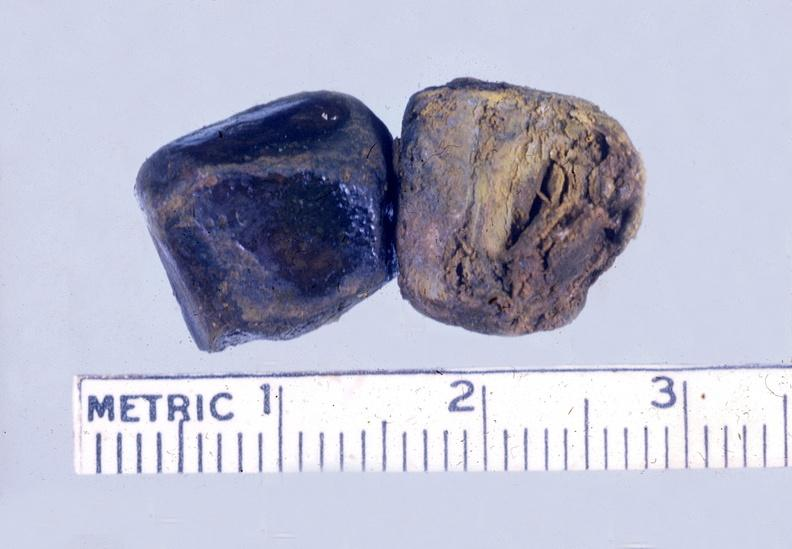what is present?
Answer the question using a single word or phrase. Hepatobiliary 